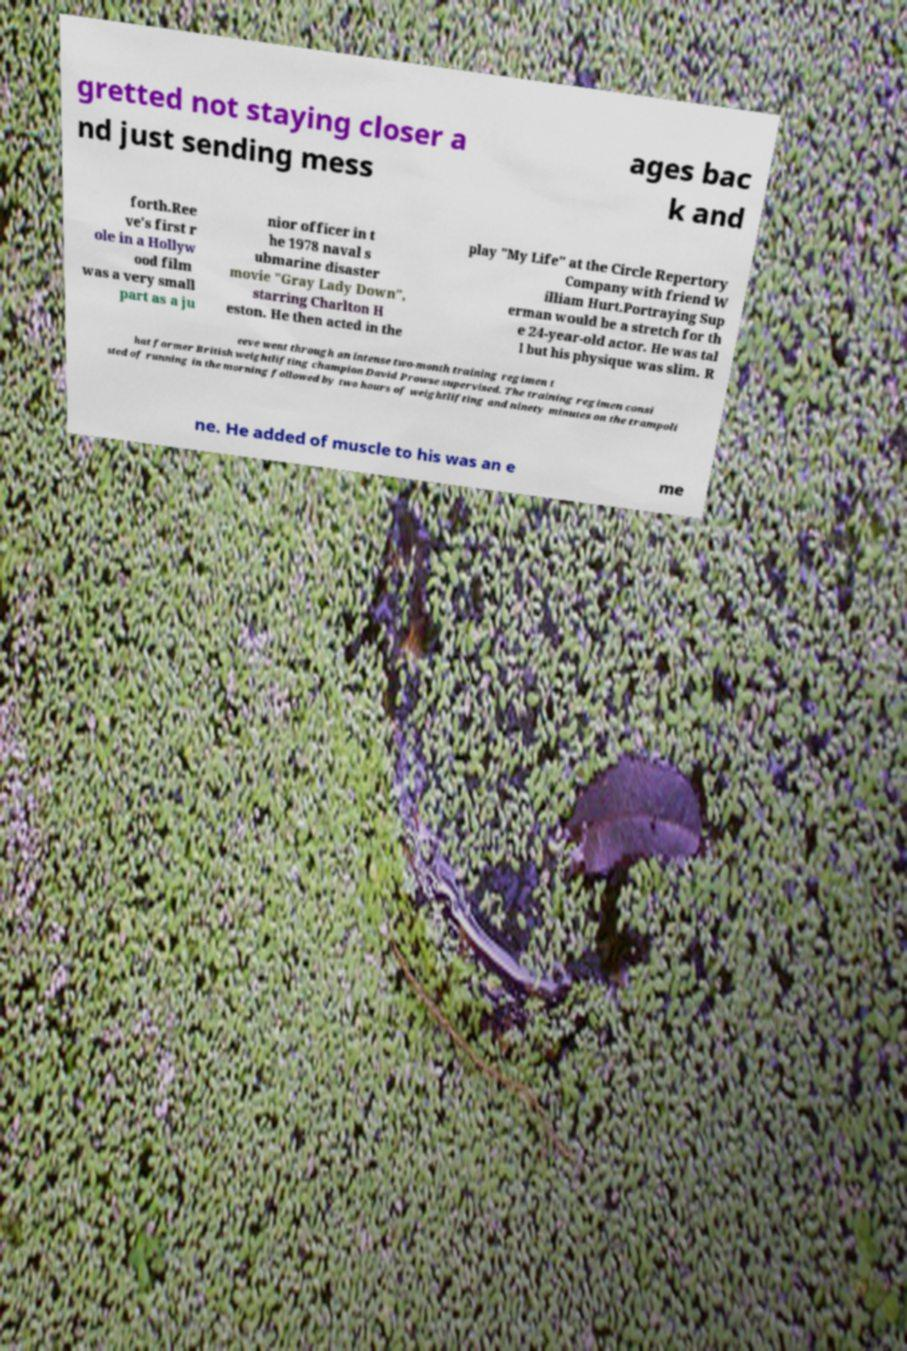Could you extract and type out the text from this image? gretted not staying closer a nd just sending mess ages bac k and forth.Ree ve's first r ole in a Hollyw ood film was a very small part as a ju nior officer in t he 1978 naval s ubmarine disaster movie "Gray Lady Down", starring Charlton H eston. He then acted in the play "My Life" at the Circle Repertory Company with friend W illiam Hurt.Portraying Sup erman would be a stretch for th e 24-year-old actor. He was tal l but his physique was slim. R eeve went through an intense two-month training regimen t hat former British weightlifting champion David Prowse supervised. The training regimen consi sted of running in the morning followed by two hours of weightlifting and ninety minutes on the trampoli ne. He added of muscle to his was an e me 